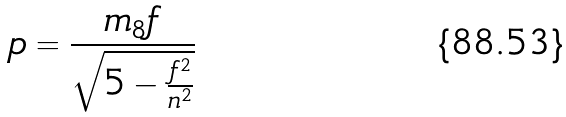Convert formula to latex. <formula><loc_0><loc_0><loc_500><loc_500>p = \frac { m _ { 8 } f } { \sqrt { 5 - \frac { f ^ { 2 } } { n ^ { 2 } } } }</formula> 